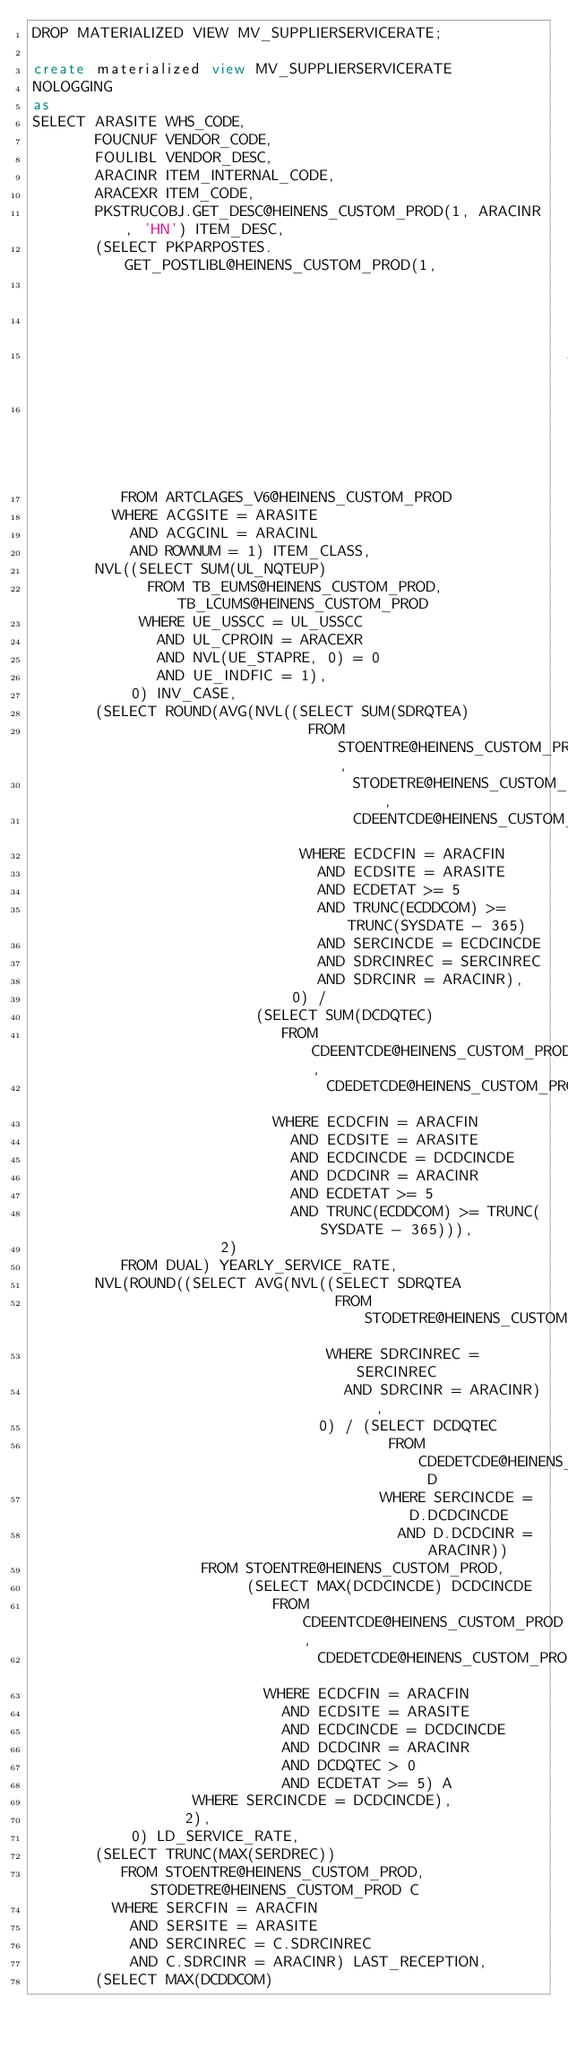Convert code to text. <code><loc_0><loc_0><loc_500><loc_500><_SQL_>DROP MATERIALIZED VIEW MV_SUPPLIERSERVICERATE;

create materialized view MV_SUPPLIERSERVICERATE
NOLOGGING
as
SELECT ARASITE WHS_CODE,
       FOUCNUF VENDOR_CODE,
       FOULIBL VENDOR_DESC,
       ARACINR ITEM_INTERNAL_CODE,
       ARACEXR ITEM_CODE,
       PKSTRUCOBJ.GET_DESC@HEINENS_CUSTOM_PROD(1, ARACINR, 'HN') ITEM_DESC,
       (SELECT PKPARPOSTES.GET_POSTLIBL@HEINENS_CUSTOM_PROD(1,
                                                            10,
                                                            1701,
                                                            ACGCCAL,
                                                            'HN')
          FROM ARTCLAGES_V6@HEINENS_CUSTOM_PROD
         WHERE ACGSITE = ARASITE
           AND ACGCINL = ARACINL
           AND ROWNUM = 1) ITEM_CLASS,
       NVL((SELECT SUM(UL_NQTEUP)
             FROM TB_EUMS@HEINENS_CUSTOM_PROD, TB_LCUMS@HEINENS_CUSTOM_PROD
            WHERE UE_USSCC = UL_USSCC
              AND UL_CPROIN = ARACEXR
              AND NVL(UE_STAPRE, 0) = 0
              AND UE_INDFIC = 1),
           0) INV_CASE,
       (SELECT ROUND(AVG(NVL((SELECT SUM(SDRQTEA)
                               FROM STOENTRE@HEINENS_CUSTOM_PROD,
                                    STODETRE@HEINENS_CUSTOM_PROD,
                                    CDEENTCDE@HEINENS_CUSTOM_PROD
                              WHERE ECDCFIN = ARACFIN
                                AND ECDSITE = ARASITE
                                AND ECDETAT >= 5
                                AND TRUNC(ECDDCOM) >= TRUNC(SYSDATE - 365)
                                AND SERCINCDE = ECDCINCDE
                                AND SDRCINREC = SERCINREC
                                AND SDRCINR = ARACINR),
                             0) /
                         (SELECT SUM(DCDQTEC)
                            FROM CDEENTCDE@HEINENS_CUSTOM_PROD,
                                 CDEDETCDE@HEINENS_CUSTOM_PROD
                           WHERE ECDCFIN = ARACFIN
                             AND ECDSITE = ARASITE
                             AND ECDCINCDE = DCDCINCDE
                             AND DCDCINR = ARACINR
                             AND ECDETAT >= 5
                             AND TRUNC(ECDDCOM) >= TRUNC(SYSDATE - 365))),
                     2)
          FROM DUAL) YEARLY_SERVICE_RATE,
       NVL(ROUND((SELECT AVG(NVL((SELECT SDRQTEA
                                  FROM STODETRE@HEINENS_CUSTOM_PROD
                                 WHERE SDRCINREC = SERCINREC
                                   AND SDRCINR = ARACINR),
                                0) / (SELECT DCDQTEC
                                        FROM CDEDETCDE@HEINENS_CUSTOM_PROD D
                                       WHERE SERCINCDE = D.DCDCINCDE
                                         AND D.DCDCINR = ARACINR))
                   FROM STOENTRE@HEINENS_CUSTOM_PROD,
                        (SELECT MAX(DCDCINCDE) DCDCINCDE
                           FROM CDEENTCDE@HEINENS_CUSTOM_PROD,
                                CDEDETCDE@HEINENS_CUSTOM_PROD
                          WHERE ECDCFIN = ARACFIN
                            AND ECDSITE = ARASITE
                            AND ECDCINCDE = DCDCINCDE
                            AND DCDCINR = ARACINR
                            AND DCDQTEC > 0
                            AND ECDETAT >= 5) A
                  WHERE SERCINCDE = DCDCINCDE),
                 2),
           0) LD_SERVICE_RATE,
       (SELECT TRUNC(MAX(SERDREC))
          FROM STOENTRE@HEINENS_CUSTOM_PROD, STODETRE@HEINENS_CUSTOM_PROD C
         WHERE SERCFIN = ARACFIN
           AND SERSITE = ARASITE
           AND SERCINREC = C.SDRCINREC
           AND C.SDRCINR = ARACINR) LAST_RECEPTION,
       (SELECT MAX(DCDDCOM)</code> 